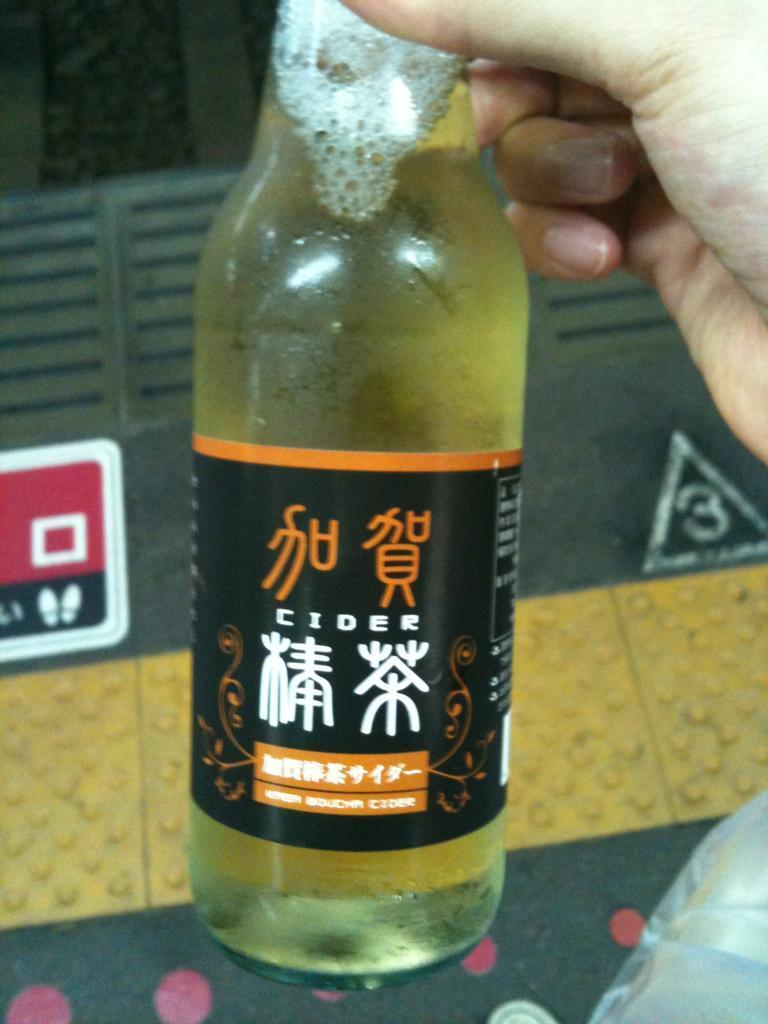<image>
Create a compact narrative representing the image presented. SOmeone is holding a bottle of cider with chinese written on it 